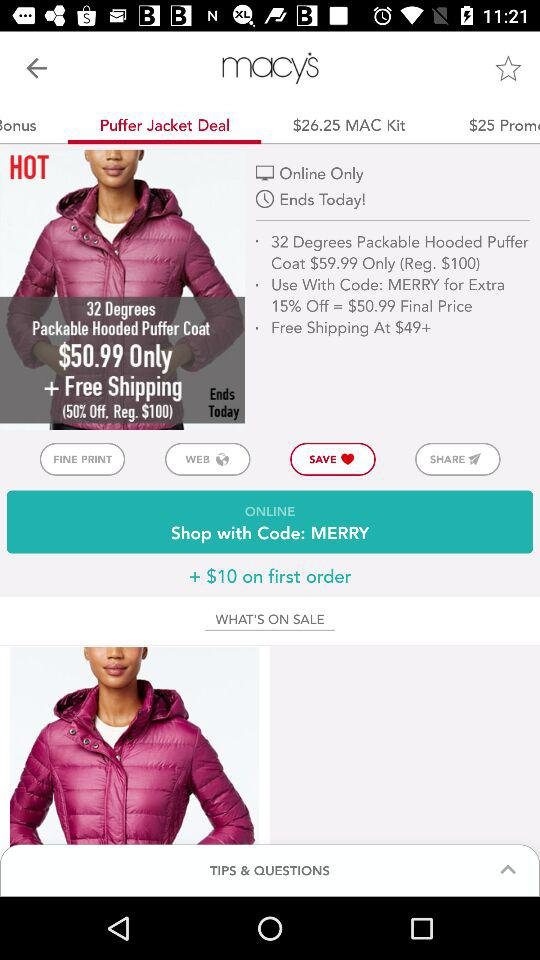What is the minimum amount at which free shipping is available? The minimum amount is $49. 